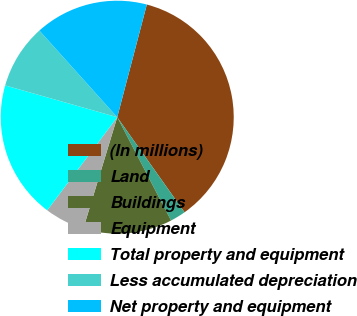Convert chart to OTSL. <chart><loc_0><loc_0><loc_500><loc_500><pie_chart><fcel>(In millions)<fcel>Land<fcel>Buildings<fcel>Equipment<fcel>Total property and equipment<fcel>Less accumulated depreciation<fcel>Net property and equipment<nl><fcel>36.11%<fcel>2.16%<fcel>12.35%<fcel>5.55%<fcel>19.14%<fcel>8.95%<fcel>15.74%<nl></chart> 